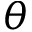<formula> <loc_0><loc_0><loc_500><loc_500>\theta</formula> 